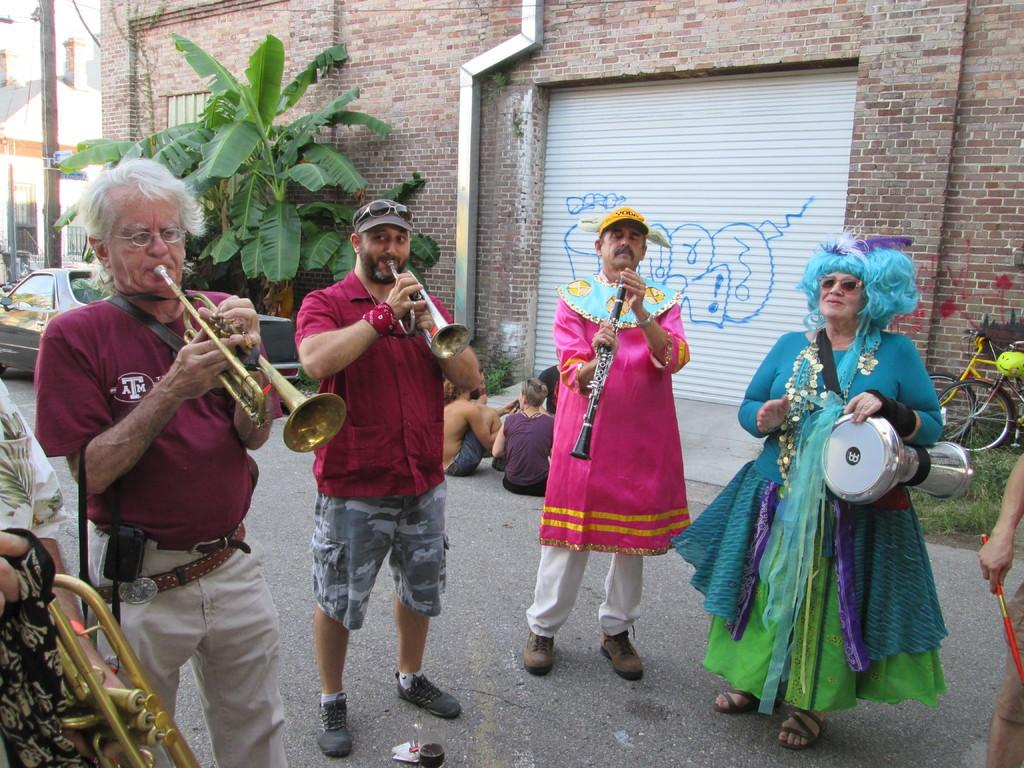What are the people in the image doing? The people in the image are playing musical instruments. Where are the people located in the image? The people are sitting on the road in the image. What else can be seen in the image besides the people? There are vehicles, buildings, and trees visible in the image. What type of brain is visible on the desk in the image? There is no brain or desk present in the image. What kind of paper is being used by the people playing musical instruments in the image? There is no paper visible in the image; the people are playing musical instruments. 